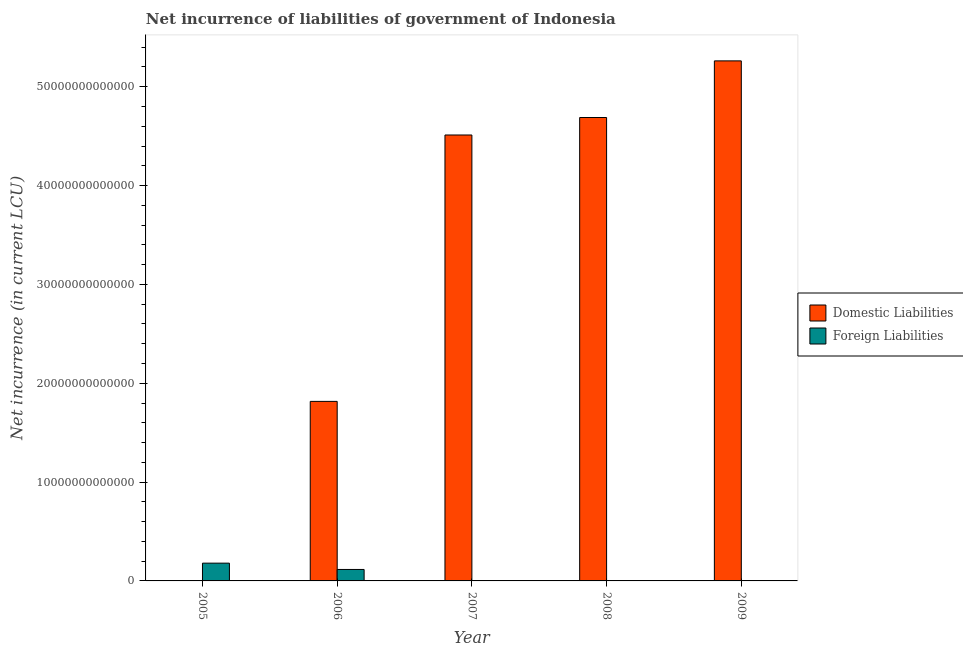Are the number of bars per tick equal to the number of legend labels?
Give a very brief answer. No. Are the number of bars on each tick of the X-axis equal?
Offer a terse response. No. How many bars are there on the 3rd tick from the right?
Offer a terse response. 1. What is the label of the 5th group of bars from the left?
Give a very brief answer. 2009. In how many cases, is the number of bars for a given year not equal to the number of legend labels?
Offer a very short reply. 4. Across all years, what is the maximum net incurrence of domestic liabilities?
Make the answer very short. 5.26e+13. What is the total net incurrence of domestic liabilities in the graph?
Provide a succinct answer. 1.63e+14. What is the difference between the net incurrence of foreign liabilities in 2005 and that in 2006?
Your answer should be very brief. 6.39e+11. What is the difference between the net incurrence of foreign liabilities in 2005 and the net incurrence of domestic liabilities in 2009?
Make the answer very short. 1.80e+12. What is the average net incurrence of foreign liabilities per year?
Give a very brief answer. 5.91e+11. In the year 2006, what is the difference between the net incurrence of foreign liabilities and net incurrence of domestic liabilities?
Ensure brevity in your answer.  0. In how many years, is the net incurrence of foreign liabilities greater than 46000000000000 LCU?
Ensure brevity in your answer.  0. What is the ratio of the net incurrence of domestic liabilities in 2006 to that in 2007?
Keep it short and to the point. 0.4. What is the difference between the highest and the second highest net incurrence of domestic liabilities?
Offer a terse response. 5.73e+12. What is the difference between the highest and the lowest net incurrence of domestic liabilities?
Give a very brief answer. 5.26e+13. In how many years, is the net incurrence of foreign liabilities greater than the average net incurrence of foreign liabilities taken over all years?
Offer a terse response. 2. How many bars are there?
Provide a succinct answer. 6. Are all the bars in the graph horizontal?
Offer a very short reply. No. What is the difference between two consecutive major ticks on the Y-axis?
Your answer should be compact. 1.00e+13. Does the graph contain any zero values?
Provide a succinct answer. Yes. Does the graph contain grids?
Ensure brevity in your answer.  No. How are the legend labels stacked?
Provide a short and direct response. Vertical. What is the title of the graph?
Offer a terse response. Net incurrence of liabilities of government of Indonesia. What is the label or title of the X-axis?
Ensure brevity in your answer.  Year. What is the label or title of the Y-axis?
Ensure brevity in your answer.  Net incurrence (in current LCU). What is the Net incurrence (in current LCU) of Domestic Liabilities in 2005?
Offer a very short reply. 0. What is the Net incurrence (in current LCU) of Foreign Liabilities in 2005?
Keep it short and to the point. 1.80e+12. What is the Net incurrence (in current LCU) of Domestic Liabilities in 2006?
Ensure brevity in your answer.  1.82e+13. What is the Net incurrence (in current LCU) in Foreign Liabilities in 2006?
Your answer should be very brief. 1.16e+12. What is the Net incurrence (in current LCU) of Domestic Liabilities in 2007?
Provide a short and direct response. 4.51e+13. What is the Net incurrence (in current LCU) in Domestic Liabilities in 2008?
Your answer should be compact. 4.69e+13. What is the Net incurrence (in current LCU) of Foreign Liabilities in 2008?
Provide a succinct answer. 0. What is the Net incurrence (in current LCU) of Domestic Liabilities in 2009?
Your answer should be compact. 5.26e+13. Across all years, what is the maximum Net incurrence (in current LCU) in Domestic Liabilities?
Offer a very short reply. 5.26e+13. Across all years, what is the maximum Net incurrence (in current LCU) in Foreign Liabilities?
Your answer should be very brief. 1.80e+12. What is the total Net incurrence (in current LCU) in Domestic Liabilities in the graph?
Provide a succinct answer. 1.63e+14. What is the total Net incurrence (in current LCU) in Foreign Liabilities in the graph?
Offer a very short reply. 2.96e+12. What is the difference between the Net incurrence (in current LCU) in Foreign Liabilities in 2005 and that in 2006?
Provide a short and direct response. 6.39e+11. What is the difference between the Net incurrence (in current LCU) in Domestic Liabilities in 2006 and that in 2007?
Offer a very short reply. -2.70e+13. What is the difference between the Net incurrence (in current LCU) of Domestic Liabilities in 2006 and that in 2008?
Your answer should be compact. -2.87e+13. What is the difference between the Net incurrence (in current LCU) of Domestic Liabilities in 2006 and that in 2009?
Your answer should be compact. -3.44e+13. What is the difference between the Net incurrence (in current LCU) in Domestic Liabilities in 2007 and that in 2008?
Ensure brevity in your answer.  -1.77e+12. What is the difference between the Net incurrence (in current LCU) of Domestic Liabilities in 2007 and that in 2009?
Ensure brevity in your answer.  -7.50e+12. What is the difference between the Net incurrence (in current LCU) in Domestic Liabilities in 2008 and that in 2009?
Your answer should be very brief. -5.73e+12. What is the average Net incurrence (in current LCU) in Domestic Liabilities per year?
Make the answer very short. 3.26e+13. What is the average Net incurrence (in current LCU) of Foreign Liabilities per year?
Your answer should be very brief. 5.91e+11. In the year 2006, what is the difference between the Net incurrence (in current LCU) of Domestic Liabilities and Net incurrence (in current LCU) of Foreign Liabilities?
Keep it short and to the point. 1.70e+13. What is the ratio of the Net incurrence (in current LCU) in Foreign Liabilities in 2005 to that in 2006?
Offer a terse response. 1.55. What is the ratio of the Net incurrence (in current LCU) of Domestic Liabilities in 2006 to that in 2007?
Keep it short and to the point. 0.4. What is the ratio of the Net incurrence (in current LCU) of Domestic Liabilities in 2006 to that in 2008?
Your response must be concise. 0.39. What is the ratio of the Net incurrence (in current LCU) in Domestic Liabilities in 2006 to that in 2009?
Ensure brevity in your answer.  0.35. What is the ratio of the Net incurrence (in current LCU) in Domestic Liabilities in 2007 to that in 2008?
Give a very brief answer. 0.96. What is the ratio of the Net incurrence (in current LCU) of Domestic Liabilities in 2007 to that in 2009?
Keep it short and to the point. 0.86. What is the ratio of the Net incurrence (in current LCU) in Domestic Liabilities in 2008 to that in 2009?
Ensure brevity in your answer.  0.89. What is the difference between the highest and the second highest Net incurrence (in current LCU) in Domestic Liabilities?
Keep it short and to the point. 5.73e+12. What is the difference between the highest and the lowest Net incurrence (in current LCU) of Domestic Liabilities?
Your answer should be very brief. 5.26e+13. What is the difference between the highest and the lowest Net incurrence (in current LCU) of Foreign Liabilities?
Ensure brevity in your answer.  1.80e+12. 